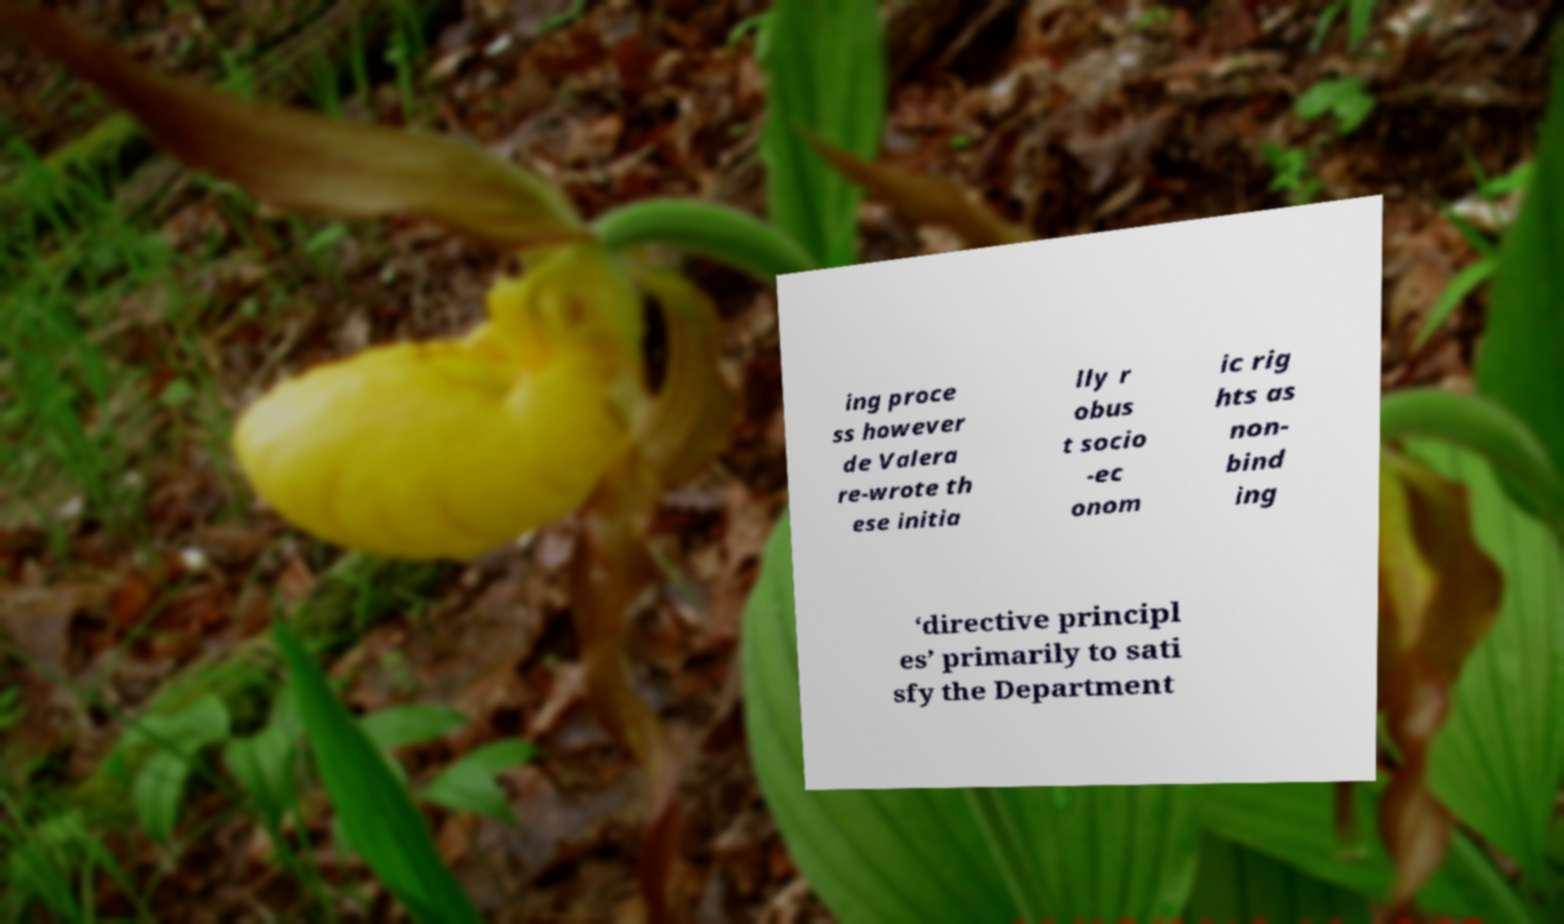Please read and relay the text visible in this image. What does it say? ing proce ss however de Valera re-wrote th ese initia lly r obus t socio -ec onom ic rig hts as non- bind ing ‘directive principl es’ primarily to sati sfy the Department 